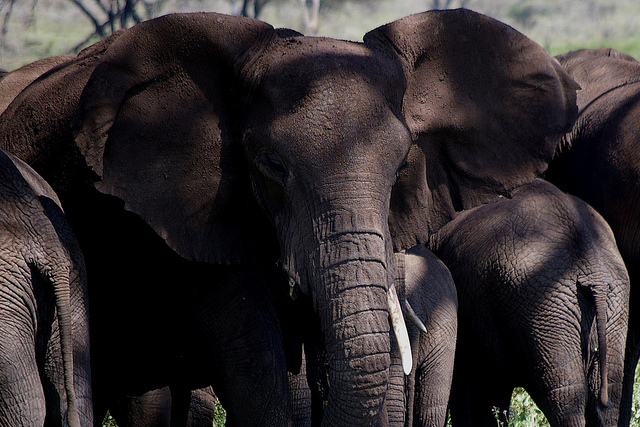<image>Why can't we see the back elephant's right eye? It is unknown why we can't see the back elephant's right eye. It could be hidden or blocked by shadow or another elephant. Why can't we see the back elephant's right eye? We cannot see the back elephant's right eye because it is covered by the other elephant's ear and it is in shadow. 